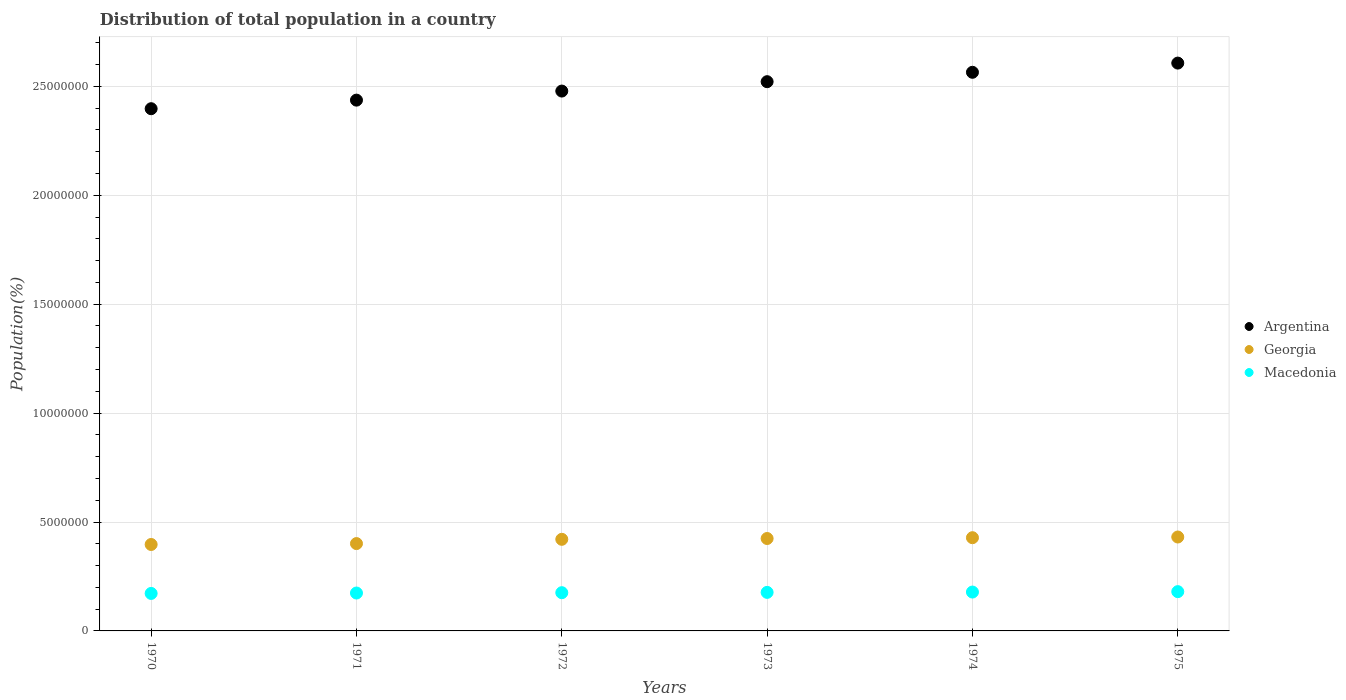Is the number of dotlines equal to the number of legend labels?
Offer a terse response. Yes. What is the population of in Macedonia in 1973?
Give a very brief answer. 1.77e+06. Across all years, what is the maximum population of in Georgia?
Offer a terse response. 4.31e+06. Across all years, what is the minimum population of in Macedonia?
Provide a short and direct response. 1.72e+06. In which year was the population of in Georgia maximum?
Offer a very short reply. 1975. In which year was the population of in Georgia minimum?
Provide a succinct answer. 1970. What is the total population of in Macedonia in the graph?
Your response must be concise. 1.06e+07. What is the difference between the population of in Georgia in 1974 and that in 1975?
Your answer should be compact. -3.17e+04. What is the difference between the population of in Argentina in 1971 and the population of in Macedonia in 1972?
Provide a succinct answer. 2.26e+07. What is the average population of in Macedonia per year?
Your response must be concise. 1.76e+06. In the year 1975, what is the difference between the population of in Macedonia and population of in Georgia?
Your answer should be very brief. -2.51e+06. In how many years, is the population of in Argentina greater than 13000000 %?
Make the answer very short. 6. What is the ratio of the population of in Argentina in 1974 to that in 1975?
Offer a terse response. 0.98. What is the difference between the highest and the second highest population of in Argentina?
Make the answer very short. 4.22e+05. What is the difference between the highest and the lowest population of in Argentina?
Offer a terse response. 2.09e+06. In how many years, is the population of in Macedonia greater than the average population of in Macedonia taken over all years?
Your answer should be compact. 3. Is the sum of the population of in Argentina in 1971 and 1972 greater than the maximum population of in Macedonia across all years?
Your answer should be compact. Yes. Is it the case that in every year, the sum of the population of in Macedonia and population of in Georgia  is greater than the population of in Argentina?
Your response must be concise. No. Is the population of in Macedonia strictly greater than the population of in Argentina over the years?
Provide a succinct answer. No. Are the values on the major ticks of Y-axis written in scientific E-notation?
Provide a succinct answer. No. Where does the legend appear in the graph?
Your response must be concise. Center right. What is the title of the graph?
Make the answer very short. Distribution of total population in a country. Does "French Polynesia" appear as one of the legend labels in the graph?
Your answer should be compact. No. What is the label or title of the X-axis?
Keep it short and to the point. Years. What is the label or title of the Y-axis?
Provide a short and direct response. Population(%). What is the Population(%) in Argentina in 1970?
Give a very brief answer. 2.40e+07. What is the Population(%) of Georgia in 1970?
Offer a terse response. 3.97e+06. What is the Population(%) of Macedonia in 1970?
Offer a terse response. 1.72e+06. What is the Population(%) of Argentina in 1971?
Offer a terse response. 2.44e+07. What is the Population(%) of Georgia in 1971?
Offer a very short reply. 4.01e+06. What is the Population(%) of Macedonia in 1971?
Keep it short and to the point. 1.74e+06. What is the Population(%) in Argentina in 1972?
Give a very brief answer. 2.48e+07. What is the Population(%) of Georgia in 1972?
Offer a very short reply. 4.21e+06. What is the Population(%) in Macedonia in 1972?
Ensure brevity in your answer.  1.75e+06. What is the Population(%) in Argentina in 1973?
Make the answer very short. 2.52e+07. What is the Population(%) of Georgia in 1973?
Your answer should be very brief. 4.24e+06. What is the Population(%) of Macedonia in 1973?
Provide a short and direct response. 1.77e+06. What is the Population(%) in Argentina in 1974?
Your answer should be compact. 2.56e+07. What is the Population(%) in Georgia in 1974?
Provide a succinct answer. 4.28e+06. What is the Population(%) of Macedonia in 1974?
Keep it short and to the point. 1.78e+06. What is the Population(%) in Argentina in 1975?
Offer a very short reply. 2.61e+07. What is the Population(%) in Georgia in 1975?
Keep it short and to the point. 4.31e+06. What is the Population(%) of Macedonia in 1975?
Your answer should be compact. 1.80e+06. Across all years, what is the maximum Population(%) in Argentina?
Provide a succinct answer. 2.61e+07. Across all years, what is the maximum Population(%) of Georgia?
Make the answer very short. 4.31e+06. Across all years, what is the maximum Population(%) in Macedonia?
Offer a terse response. 1.80e+06. Across all years, what is the minimum Population(%) of Argentina?
Make the answer very short. 2.40e+07. Across all years, what is the minimum Population(%) of Georgia?
Give a very brief answer. 3.97e+06. Across all years, what is the minimum Population(%) in Macedonia?
Provide a succinct answer. 1.72e+06. What is the total Population(%) in Argentina in the graph?
Provide a short and direct response. 1.50e+08. What is the total Population(%) of Georgia in the graph?
Ensure brevity in your answer.  2.50e+07. What is the total Population(%) in Macedonia in the graph?
Your answer should be compact. 1.06e+07. What is the difference between the Population(%) in Argentina in 1970 and that in 1971?
Provide a succinct answer. -3.93e+05. What is the difference between the Population(%) in Georgia in 1970 and that in 1971?
Provide a short and direct response. -4.16e+04. What is the difference between the Population(%) of Macedonia in 1970 and that in 1971?
Your answer should be compact. -1.87e+04. What is the difference between the Population(%) of Argentina in 1970 and that in 1972?
Offer a terse response. -8.10e+05. What is the difference between the Population(%) in Georgia in 1970 and that in 1972?
Offer a very short reply. -2.38e+05. What is the difference between the Population(%) of Macedonia in 1970 and that in 1972?
Your answer should be very brief. -3.42e+04. What is the difference between the Population(%) in Argentina in 1970 and that in 1973?
Your answer should be compact. -1.24e+06. What is the difference between the Population(%) in Georgia in 1970 and that in 1973?
Offer a very short reply. -2.75e+05. What is the difference between the Population(%) of Macedonia in 1970 and that in 1973?
Your response must be concise. -4.82e+04. What is the difference between the Population(%) in Argentina in 1970 and that in 1974?
Your answer should be compact. -1.67e+06. What is the difference between the Population(%) of Georgia in 1970 and that in 1974?
Give a very brief answer. -3.12e+05. What is the difference between the Population(%) in Macedonia in 1970 and that in 1974?
Provide a short and direct response. -6.36e+04. What is the difference between the Population(%) of Argentina in 1970 and that in 1975?
Your response must be concise. -2.09e+06. What is the difference between the Population(%) of Georgia in 1970 and that in 1975?
Keep it short and to the point. -3.43e+05. What is the difference between the Population(%) of Macedonia in 1970 and that in 1975?
Provide a succinct answer. -8.22e+04. What is the difference between the Population(%) in Argentina in 1971 and that in 1972?
Your response must be concise. -4.17e+05. What is the difference between the Population(%) in Georgia in 1971 and that in 1972?
Offer a terse response. -1.96e+05. What is the difference between the Population(%) of Macedonia in 1971 and that in 1972?
Your answer should be very brief. -1.54e+04. What is the difference between the Population(%) of Argentina in 1971 and that in 1973?
Provide a succinct answer. -8.47e+05. What is the difference between the Population(%) of Georgia in 1971 and that in 1973?
Provide a short and direct response. -2.33e+05. What is the difference between the Population(%) in Macedonia in 1971 and that in 1973?
Keep it short and to the point. -2.95e+04. What is the difference between the Population(%) in Argentina in 1971 and that in 1974?
Your answer should be very brief. -1.28e+06. What is the difference between the Population(%) in Georgia in 1971 and that in 1974?
Provide a short and direct response. -2.70e+05. What is the difference between the Population(%) of Macedonia in 1971 and that in 1974?
Your answer should be compact. -4.49e+04. What is the difference between the Population(%) of Argentina in 1971 and that in 1975?
Provide a short and direct response. -1.70e+06. What is the difference between the Population(%) of Georgia in 1971 and that in 1975?
Keep it short and to the point. -3.02e+05. What is the difference between the Population(%) of Macedonia in 1971 and that in 1975?
Ensure brevity in your answer.  -6.35e+04. What is the difference between the Population(%) in Argentina in 1972 and that in 1973?
Your response must be concise. -4.30e+05. What is the difference between the Population(%) of Georgia in 1972 and that in 1973?
Offer a very short reply. -3.72e+04. What is the difference between the Population(%) in Macedonia in 1972 and that in 1973?
Provide a short and direct response. -1.40e+04. What is the difference between the Population(%) in Argentina in 1972 and that in 1974?
Provide a short and direct response. -8.62e+05. What is the difference between the Population(%) of Georgia in 1972 and that in 1974?
Provide a short and direct response. -7.42e+04. What is the difference between the Population(%) of Macedonia in 1972 and that in 1974?
Offer a very short reply. -2.94e+04. What is the difference between the Population(%) of Argentina in 1972 and that in 1975?
Provide a short and direct response. -1.28e+06. What is the difference between the Population(%) of Georgia in 1972 and that in 1975?
Provide a succinct answer. -1.06e+05. What is the difference between the Population(%) of Macedonia in 1972 and that in 1975?
Make the answer very short. -4.81e+04. What is the difference between the Population(%) in Argentina in 1973 and that in 1974?
Provide a short and direct response. -4.31e+05. What is the difference between the Population(%) in Georgia in 1973 and that in 1974?
Offer a very short reply. -3.70e+04. What is the difference between the Population(%) of Macedonia in 1973 and that in 1974?
Make the answer very short. -1.54e+04. What is the difference between the Population(%) of Argentina in 1973 and that in 1975?
Provide a short and direct response. -8.54e+05. What is the difference between the Population(%) in Georgia in 1973 and that in 1975?
Provide a succinct answer. -6.87e+04. What is the difference between the Population(%) in Macedonia in 1973 and that in 1975?
Offer a terse response. -3.40e+04. What is the difference between the Population(%) of Argentina in 1974 and that in 1975?
Your answer should be very brief. -4.22e+05. What is the difference between the Population(%) of Georgia in 1974 and that in 1975?
Offer a very short reply. -3.17e+04. What is the difference between the Population(%) in Macedonia in 1974 and that in 1975?
Make the answer very short. -1.86e+04. What is the difference between the Population(%) of Argentina in 1970 and the Population(%) of Georgia in 1971?
Your answer should be very brief. 2.00e+07. What is the difference between the Population(%) of Argentina in 1970 and the Population(%) of Macedonia in 1971?
Make the answer very short. 2.22e+07. What is the difference between the Population(%) in Georgia in 1970 and the Population(%) in Macedonia in 1971?
Ensure brevity in your answer.  2.23e+06. What is the difference between the Population(%) in Argentina in 1970 and the Population(%) in Georgia in 1972?
Keep it short and to the point. 1.98e+07. What is the difference between the Population(%) in Argentina in 1970 and the Population(%) in Macedonia in 1972?
Give a very brief answer. 2.22e+07. What is the difference between the Population(%) of Georgia in 1970 and the Population(%) of Macedonia in 1972?
Your response must be concise. 2.21e+06. What is the difference between the Population(%) of Argentina in 1970 and the Population(%) of Georgia in 1973?
Keep it short and to the point. 1.97e+07. What is the difference between the Population(%) of Argentina in 1970 and the Population(%) of Macedonia in 1973?
Your answer should be compact. 2.22e+07. What is the difference between the Population(%) in Georgia in 1970 and the Population(%) in Macedonia in 1973?
Your answer should be very brief. 2.20e+06. What is the difference between the Population(%) of Argentina in 1970 and the Population(%) of Georgia in 1974?
Keep it short and to the point. 1.97e+07. What is the difference between the Population(%) of Argentina in 1970 and the Population(%) of Macedonia in 1974?
Your answer should be compact. 2.22e+07. What is the difference between the Population(%) of Georgia in 1970 and the Population(%) of Macedonia in 1974?
Provide a succinct answer. 2.18e+06. What is the difference between the Population(%) in Argentina in 1970 and the Population(%) in Georgia in 1975?
Make the answer very short. 1.97e+07. What is the difference between the Population(%) of Argentina in 1970 and the Population(%) of Macedonia in 1975?
Ensure brevity in your answer.  2.22e+07. What is the difference between the Population(%) of Georgia in 1970 and the Population(%) of Macedonia in 1975?
Keep it short and to the point. 2.16e+06. What is the difference between the Population(%) in Argentina in 1971 and the Population(%) in Georgia in 1972?
Make the answer very short. 2.02e+07. What is the difference between the Population(%) in Argentina in 1971 and the Population(%) in Macedonia in 1972?
Your response must be concise. 2.26e+07. What is the difference between the Population(%) of Georgia in 1971 and the Population(%) of Macedonia in 1972?
Provide a short and direct response. 2.25e+06. What is the difference between the Population(%) of Argentina in 1971 and the Population(%) of Georgia in 1973?
Make the answer very short. 2.01e+07. What is the difference between the Population(%) in Argentina in 1971 and the Population(%) in Macedonia in 1973?
Your answer should be compact. 2.26e+07. What is the difference between the Population(%) of Georgia in 1971 and the Population(%) of Macedonia in 1973?
Your response must be concise. 2.24e+06. What is the difference between the Population(%) of Argentina in 1971 and the Population(%) of Georgia in 1974?
Provide a short and direct response. 2.01e+07. What is the difference between the Population(%) of Argentina in 1971 and the Population(%) of Macedonia in 1974?
Your answer should be compact. 2.26e+07. What is the difference between the Population(%) in Georgia in 1971 and the Population(%) in Macedonia in 1974?
Offer a very short reply. 2.23e+06. What is the difference between the Population(%) of Argentina in 1971 and the Population(%) of Georgia in 1975?
Your response must be concise. 2.01e+07. What is the difference between the Population(%) in Argentina in 1971 and the Population(%) in Macedonia in 1975?
Provide a short and direct response. 2.26e+07. What is the difference between the Population(%) in Georgia in 1971 and the Population(%) in Macedonia in 1975?
Provide a short and direct response. 2.21e+06. What is the difference between the Population(%) in Argentina in 1972 and the Population(%) in Georgia in 1973?
Your response must be concise. 2.05e+07. What is the difference between the Population(%) of Argentina in 1972 and the Population(%) of Macedonia in 1973?
Offer a very short reply. 2.30e+07. What is the difference between the Population(%) in Georgia in 1972 and the Population(%) in Macedonia in 1973?
Your response must be concise. 2.44e+06. What is the difference between the Population(%) in Argentina in 1972 and the Population(%) in Georgia in 1974?
Your answer should be very brief. 2.05e+07. What is the difference between the Population(%) of Argentina in 1972 and the Population(%) of Macedonia in 1974?
Provide a short and direct response. 2.30e+07. What is the difference between the Population(%) in Georgia in 1972 and the Population(%) in Macedonia in 1974?
Your response must be concise. 2.42e+06. What is the difference between the Population(%) in Argentina in 1972 and the Population(%) in Georgia in 1975?
Your answer should be very brief. 2.05e+07. What is the difference between the Population(%) in Argentina in 1972 and the Population(%) in Macedonia in 1975?
Offer a terse response. 2.30e+07. What is the difference between the Population(%) in Georgia in 1972 and the Population(%) in Macedonia in 1975?
Keep it short and to the point. 2.40e+06. What is the difference between the Population(%) in Argentina in 1973 and the Population(%) in Georgia in 1974?
Provide a succinct answer. 2.09e+07. What is the difference between the Population(%) in Argentina in 1973 and the Population(%) in Macedonia in 1974?
Keep it short and to the point. 2.34e+07. What is the difference between the Population(%) in Georgia in 1973 and the Population(%) in Macedonia in 1974?
Offer a very short reply. 2.46e+06. What is the difference between the Population(%) of Argentina in 1973 and the Population(%) of Georgia in 1975?
Offer a very short reply. 2.09e+07. What is the difference between the Population(%) of Argentina in 1973 and the Population(%) of Macedonia in 1975?
Your answer should be compact. 2.34e+07. What is the difference between the Population(%) in Georgia in 1973 and the Population(%) in Macedonia in 1975?
Give a very brief answer. 2.44e+06. What is the difference between the Population(%) of Argentina in 1974 and the Population(%) of Georgia in 1975?
Your response must be concise. 2.13e+07. What is the difference between the Population(%) of Argentina in 1974 and the Population(%) of Macedonia in 1975?
Ensure brevity in your answer.  2.38e+07. What is the difference between the Population(%) in Georgia in 1974 and the Population(%) in Macedonia in 1975?
Ensure brevity in your answer.  2.48e+06. What is the average Population(%) in Argentina per year?
Your answer should be compact. 2.50e+07. What is the average Population(%) of Georgia per year?
Provide a short and direct response. 4.17e+06. What is the average Population(%) of Macedonia per year?
Your answer should be very brief. 1.76e+06. In the year 1970, what is the difference between the Population(%) of Argentina and Population(%) of Georgia?
Provide a short and direct response. 2.00e+07. In the year 1970, what is the difference between the Population(%) of Argentina and Population(%) of Macedonia?
Give a very brief answer. 2.23e+07. In the year 1970, what is the difference between the Population(%) of Georgia and Population(%) of Macedonia?
Your response must be concise. 2.25e+06. In the year 1971, what is the difference between the Population(%) of Argentina and Population(%) of Georgia?
Give a very brief answer. 2.04e+07. In the year 1971, what is the difference between the Population(%) of Argentina and Population(%) of Macedonia?
Provide a succinct answer. 2.26e+07. In the year 1971, what is the difference between the Population(%) in Georgia and Population(%) in Macedonia?
Your answer should be very brief. 2.27e+06. In the year 1972, what is the difference between the Population(%) of Argentina and Population(%) of Georgia?
Your response must be concise. 2.06e+07. In the year 1972, what is the difference between the Population(%) of Argentina and Population(%) of Macedonia?
Your answer should be compact. 2.30e+07. In the year 1972, what is the difference between the Population(%) of Georgia and Population(%) of Macedonia?
Offer a terse response. 2.45e+06. In the year 1973, what is the difference between the Population(%) in Argentina and Population(%) in Georgia?
Your answer should be compact. 2.10e+07. In the year 1973, what is the difference between the Population(%) of Argentina and Population(%) of Macedonia?
Give a very brief answer. 2.34e+07. In the year 1973, what is the difference between the Population(%) of Georgia and Population(%) of Macedonia?
Your answer should be very brief. 2.47e+06. In the year 1974, what is the difference between the Population(%) of Argentina and Population(%) of Georgia?
Give a very brief answer. 2.14e+07. In the year 1974, what is the difference between the Population(%) in Argentina and Population(%) in Macedonia?
Keep it short and to the point. 2.39e+07. In the year 1974, what is the difference between the Population(%) of Georgia and Population(%) of Macedonia?
Your answer should be compact. 2.50e+06. In the year 1975, what is the difference between the Population(%) of Argentina and Population(%) of Georgia?
Your answer should be very brief. 2.18e+07. In the year 1975, what is the difference between the Population(%) in Argentina and Population(%) in Macedonia?
Offer a terse response. 2.43e+07. In the year 1975, what is the difference between the Population(%) in Georgia and Population(%) in Macedonia?
Your response must be concise. 2.51e+06. What is the ratio of the Population(%) in Argentina in 1970 to that in 1971?
Give a very brief answer. 0.98. What is the ratio of the Population(%) of Argentina in 1970 to that in 1972?
Ensure brevity in your answer.  0.97. What is the ratio of the Population(%) in Georgia in 1970 to that in 1972?
Make the answer very short. 0.94. What is the ratio of the Population(%) in Macedonia in 1970 to that in 1972?
Give a very brief answer. 0.98. What is the ratio of the Population(%) in Argentina in 1970 to that in 1973?
Keep it short and to the point. 0.95. What is the ratio of the Population(%) in Georgia in 1970 to that in 1973?
Your answer should be compact. 0.94. What is the ratio of the Population(%) of Macedonia in 1970 to that in 1973?
Your response must be concise. 0.97. What is the ratio of the Population(%) in Argentina in 1970 to that in 1974?
Provide a succinct answer. 0.93. What is the ratio of the Population(%) in Georgia in 1970 to that in 1974?
Your answer should be compact. 0.93. What is the ratio of the Population(%) of Macedonia in 1970 to that in 1974?
Your response must be concise. 0.96. What is the ratio of the Population(%) of Argentina in 1970 to that in 1975?
Keep it short and to the point. 0.92. What is the ratio of the Population(%) in Georgia in 1970 to that in 1975?
Give a very brief answer. 0.92. What is the ratio of the Population(%) of Macedonia in 1970 to that in 1975?
Keep it short and to the point. 0.95. What is the ratio of the Population(%) in Argentina in 1971 to that in 1972?
Ensure brevity in your answer.  0.98. What is the ratio of the Population(%) in Georgia in 1971 to that in 1972?
Your answer should be very brief. 0.95. What is the ratio of the Population(%) of Argentina in 1971 to that in 1973?
Your answer should be compact. 0.97. What is the ratio of the Population(%) in Georgia in 1971 to that in 1973?
Your answer should be compact. 0.95. What is the ratio of the Population(%) in Macedonia in 1971 to that in 1973?
Offer a very short reply. 0.98. What is the ratio of the Population(%) of Argentina in 1971 to that in 1974?
Give a very brief answer. 0.95. What is the ratio of the Population(%) of Georgia in 1971 to that in 1974?
Provide a succinct answer. 0.94. What is the ratio of the Population(%) of Macedonia in 1971 to that in 1974?
Ensure brevity in your answer.  0.97. What is the ratio of the Population(%) in Argentina in 1971 to that in 1975?
Your answer should be very brief. 0.93. What is the ratio of the Population(%) of Georgia in 1971 to that in 1975?
Offer a terse response. 0.93. What is the ratio of the Population(%) of Macedonia in 1971 to that in 1975?
Give a very brief answer. 0.96. What is the ratio of the Population(%) of Argentina in 1972 to that in 1973?
Keep it short and to the point. 0.98. What is the ratio of the Population(%) of Argentina in 1972 to that in 1974?
Provide a short and direct response. 0.97. What is the ratio of the Population(%) of Georgia in 1972 to that in 1974?
Provide a succinct answer. 0.98. What is the ratio of the Population(%) of Macedonia in 1972 to that in 1974?
Provide a short and direct response. 0.98. What is the ratio of the Population(%) of Argentina in 1972 to that in 1975?
Keep it short and to the point. 0.95. What is the ratio of the Population(%) of Georgia in 1972 to that in 1975?
Offer a terse response. 0.98. What is the ratio of the Population(%) in Macedonia in 1972 to that in 1975?
Keep it short and to the point. 0.97. What is the ratio of the Population(%) of Argentina in 1973 to that in 1974?
Offer a very short reply. 0.98. What is the ratio of the Population(%) of Argentina in 1973 to that in 1975?
Offer a very short reply. 0.97. What is the ratio of the Population(%) in Georgia in 1973 to that in 1975?
Provide a short and direct response. 0.98. What is the ratio of the Population(%) of Macedonia in 1973 to that in 1975?
Your answer should be compact. 0.98. What is the ratio of the Population(%) in Argentina in 1974 to that in 1975?
Provide a short and direct response. 0.98. What is the difference between the highest and the second highest Population(%) in Argentina?
Keep it short and to the point. 4.22e+05. What is the difference between the highest and the second highest Population(%) of Georgia?
Ensure brevity in your answer.  3.17e+04. What is the difference between the highest and the second highest Population(%) in Macedonia?
Your response must be concise. 1.86e+04. What is the difference between the highest and the lowest Population(%) in Argentina?
Provide a succinct answer. 2.09e+06. What is the difference between the highest and the lowest Population(%) of Georgia?
Your answer should be very brief. 3.43e+05. What is the difference between the highest and the lowest Population(%) in Macedonia?
Keep it short and to the point. 8.22e+04. 